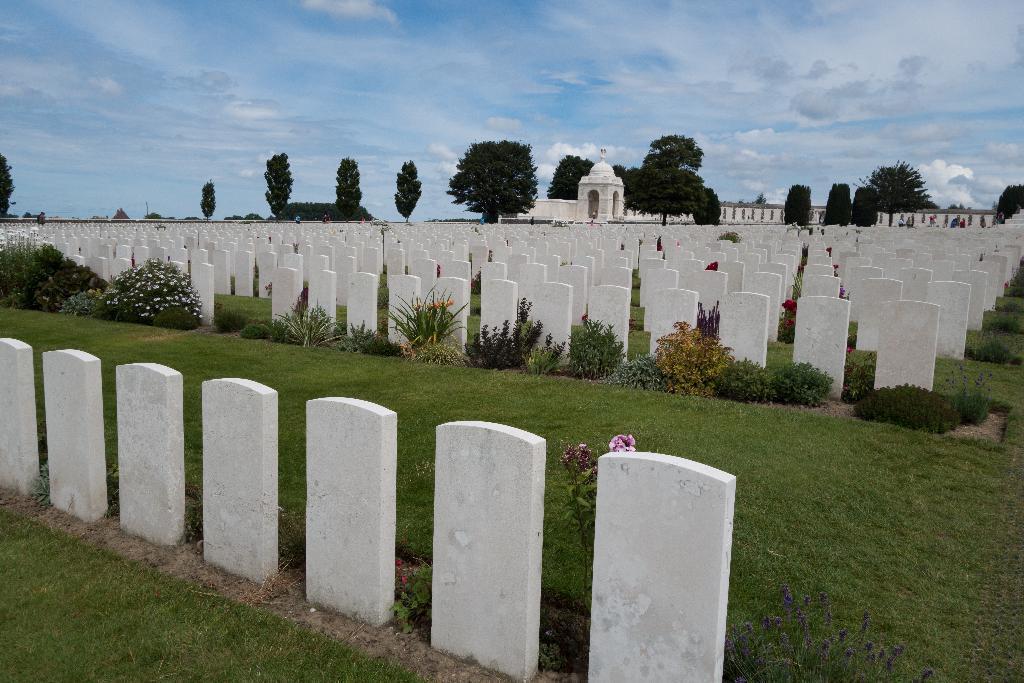Can you describe this image briefly? This is the picture of a place where we have some cemeteries on the floor and also we can see some plants, trees and a building to the side. 